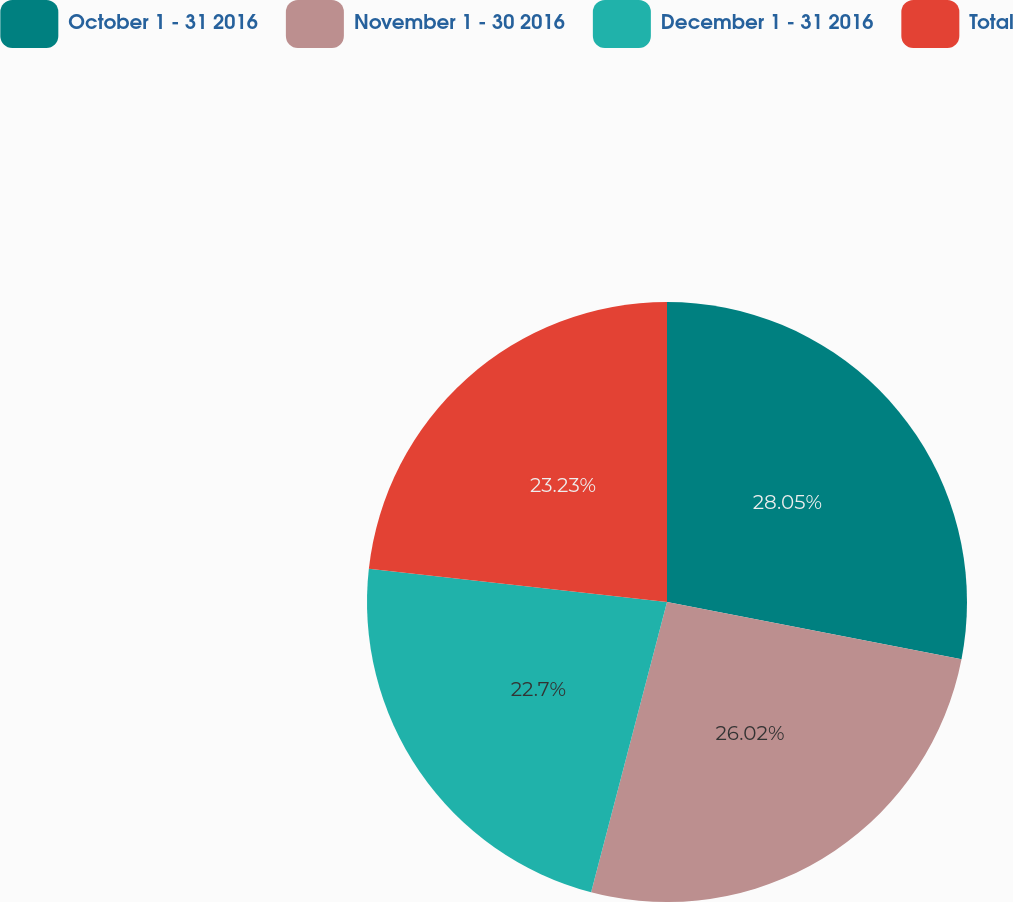Convert chart to OTSL. <chart><loc_0><loc_0><loc_500><loc_500><pie_chart><fcel>October 1 - 31 2016<fcel>November 1 - 30 2016<fcel>December 1 - 31 2016<fcel>Total<nl><fcel>28.05%<fcel>26.02%<fcel>22.7%<fcel>23.23%<nl></chart> 